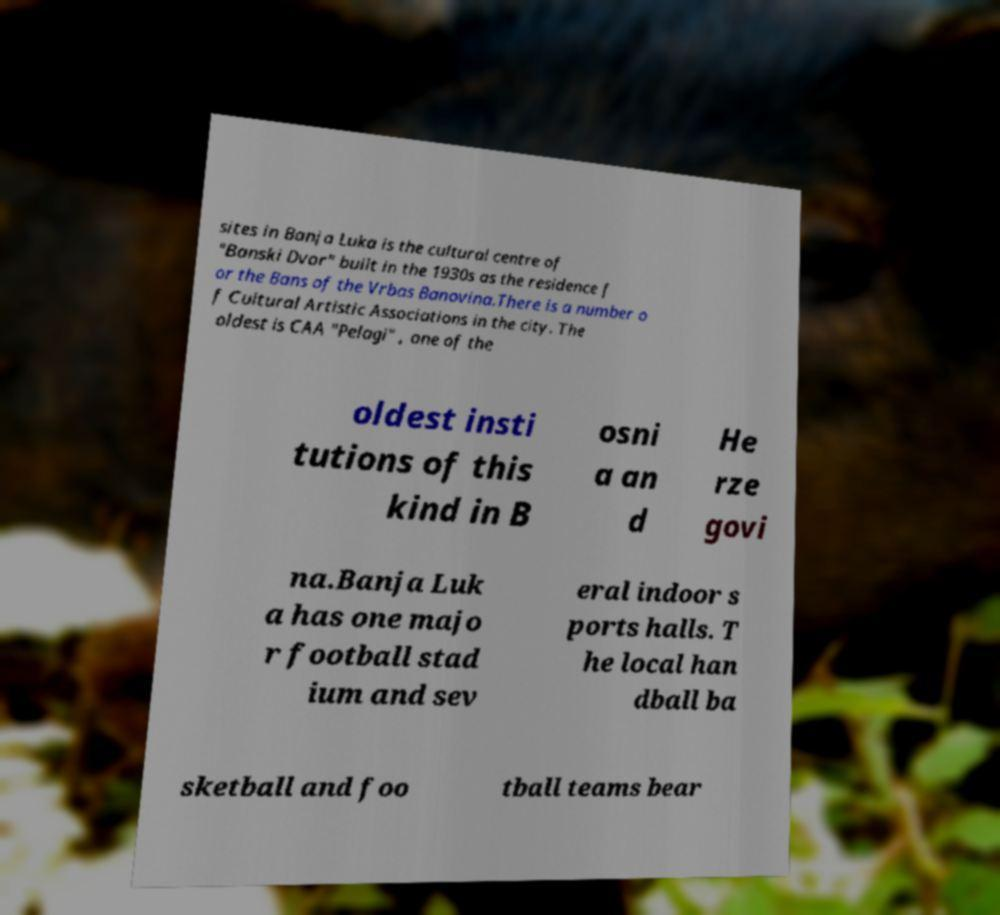Can you read and provide the text displayed in the image?This photo seems to have some interesting text. Can you extract and type it out for me? sites in Banja Luka is the cultural centre of "Banski Dvor" built in the 1930s as the residence f or the Bans of the Vrbas Banovina.There is a number o f Cultural Artistic Associations in the city. The oldest is CAA "Pelagi" , one of the oldest insti tutions of this kind in B osni a an d He rze govi na.Banja Luk a has one majo r football stad ium and sev eral indoor s ports halls. T he local han dball ba sketball and foo tball teams bear 